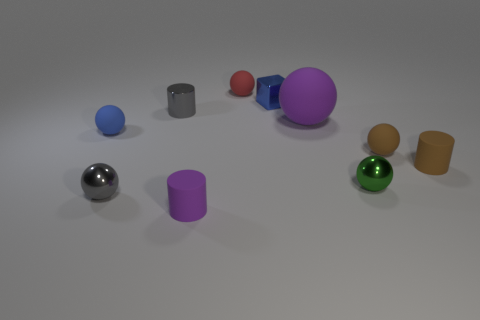Subtract 3 spheres. How many spheres are left? 3 Subtract all purple balls. How many balls are left? 5 Subtract all green balls. How many balls are left? 5 Subtract all green balls. Subtract all cyan cubes. How many balls are left? 5 Subtract all cubes. How many objects are left? 9 Add 3 tiny brown metallic objects. How many tiny brown metallic objects exist? 3 Subtract 0 gray blocks. How many objects are left? 10 Subtract all small green balls. Subtract all small red matte balls. How many objects are left? 8 Add 4 tiny red rubber things. How many tiny red rubber things are left? 5 